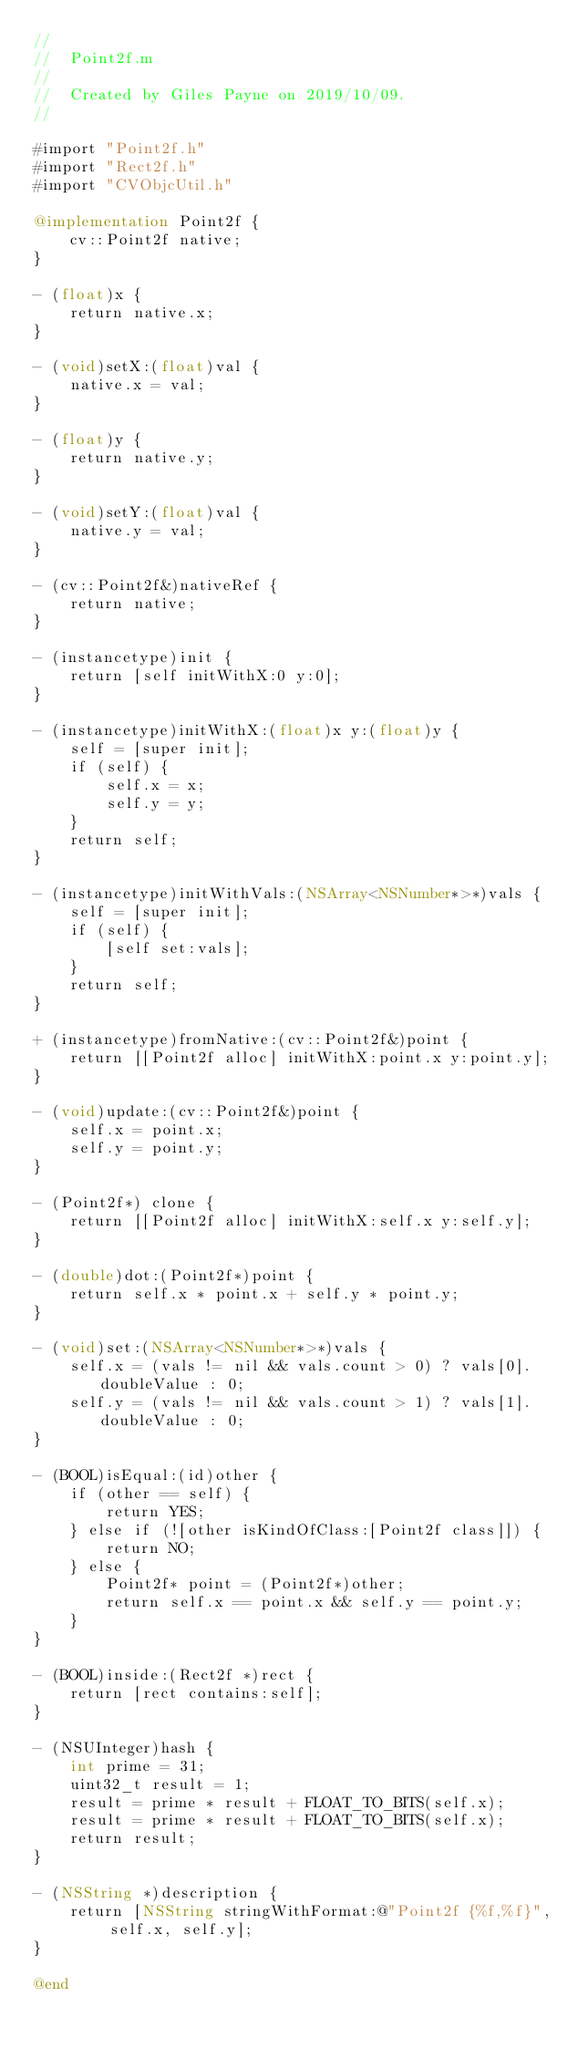Convert code to text. <code><loc_0><loc_0><loc_500><loc_500><_ObjectiveC_>//
//  Point2f.m
//
//  Created by Giles Payne on 2019/10/09.
//

#import "Point2f.h"
#import "Rect2f.h"
#import "CVObjcUtil.h"

@implementation Point2f {
    cv::Point2f native;
}

- (float)x {
    return native.x;
}

- (void)setX:(float)val {
    native.x = val;
}

- (float)y {
    return native.y;
}

- (void)setY:(float)val {
    native.y = val;
}

- (cv::Point2f&)nativeRef {
    return native;
}

- (instancetype)init {
    return [self initWithX:0 y:0];
}

- (instancetype)initWithX:(float)x y:(float)y {
    self = [super init];
    if (self) {
        self.x = x;
        self.y = y;
    }
    return self;
}

- (instancetype)initWithVals:(NSArray<NSNumber*>*)vals {
    self = [super init];
    if (self) {
        [self set:vals];
    }
    return self;
}

+ (instancetype)fromNative:(cv::Point2f&)point {
    return [[Point2f alloc] initWithX:point.x y:point.y];
}

- (void)update:(cv::Point2f&)point {
    self.x = point.x;
    self.y = point.y;
}

- (Point2f*) clone {
    return [[Point2f alloc] initWithX:self.x y:self.y];
}

- (double)dot:(Point2f*)point {
    return self.x * point.x + self.y * point.y;
}

- (void)set:(NSArray<NSNumber*>*)vals {
    self.x = (vals != nil && vals.count > 0) ? vals[0].doubleValue : 0;
    self.y = (vals != nil && vals.count > 1) ? vals[1].doubleValue : 0;
}

- (BOOL)isEqual:(id)other {
    if (other == self) {
        return YES;
    } else if (![other isKindOfClass:[Point2f class]]) {
        return NO;
    } else {
        Point2f* point = (Point2f*)other;
        return self.x == point.x && self.y == point.y;
    }
}

- (BOOL)inside:(Rect2f *)rect {
    return [rect contains:self];
}

- (NSUInteger)hash {
    int prime = 31;
    uint32_t result = 1;
    result = prime * result + FLOAT_TO_BITS(self.x);
    result = prime * result + FLOAT_TO_BITS(self.x);
    return result;
}

- (NSString *)description {
    return [NSString stringWithFormat:@"Point2f {%f,%f}", self.x, self.y];
}

@end
</code> 